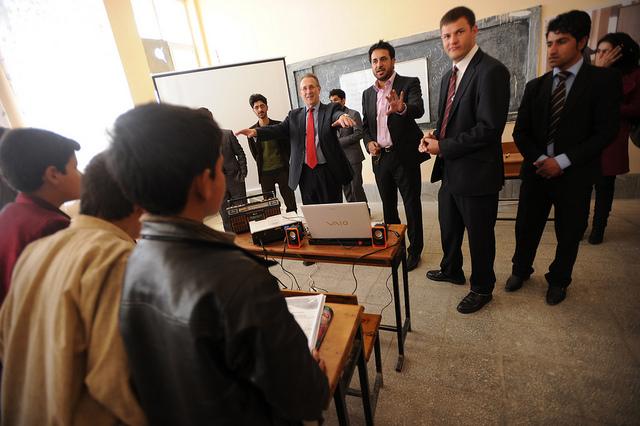Are these people real?
Write a very short answer. Yes. How many men are wearing ties?
Give a very brief answer. 3. What are the colors in the nearest table?
Give a very brief answer. Brown. How many people are shown?
Write a very short answer. 11. Is the laptop connected to speakers?
Concise answer only. Yes. What material is covering the ground?
Answer briefly. Carpet. 